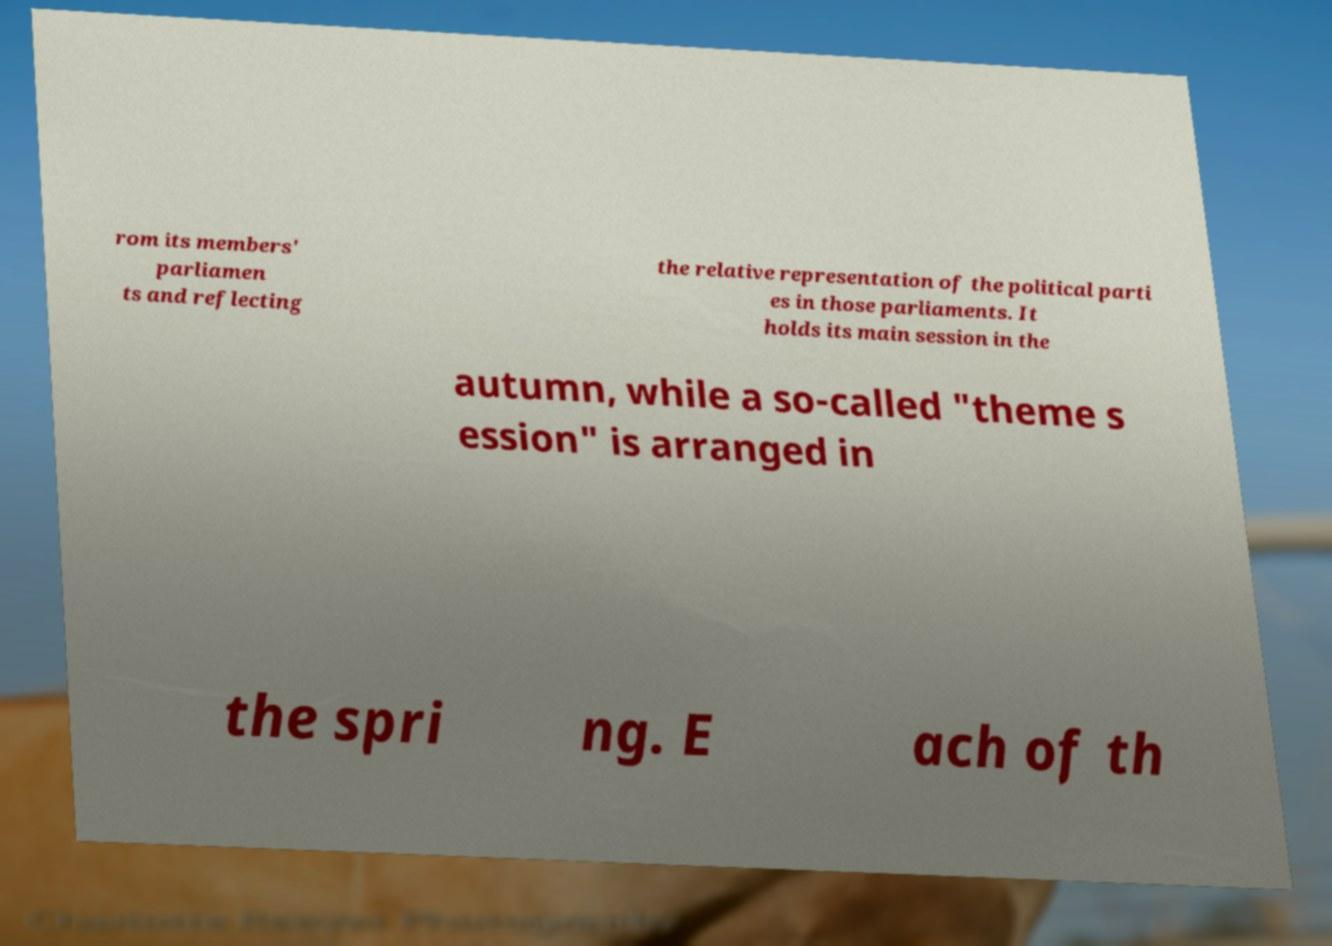Can you read and provide the text displayed in the image?This photo seems to have some interesting text. Can you extract and type it out for me? rom its members' parliamen ts and reflecting the relative representation of the political parti es in those parliaments. It holds its main session in the autumn, while a so-called "theme s ession" is arranged in the spri ng. E ach of th 